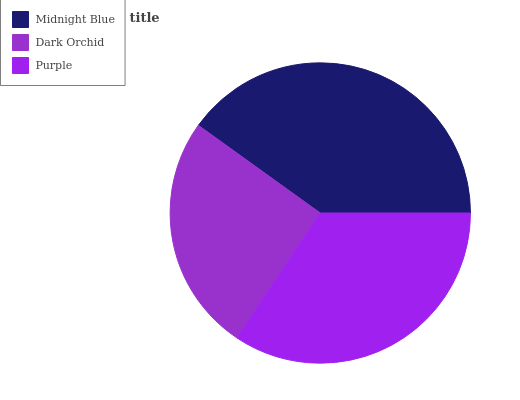Is Dark Orchid the minimum?
Answer yes or no. Yes. Is Midnight Blue the maximum?
Answer yes or no. Yes. Is Purple the minimum?
Answer yes or no. No. Is Purple the maximum?
Answer yes or no. No. Is Purple greater than Dark Orchid?
Answer yes or no. Yes. Is Dark Orchid less than Purple?
Answer yes or no. Yes. Is Dark Orchid greater than Purple?
Answer yes or no. No. Is Purple less than Dark Orchid?
Answer yes or no. No. Is Purple the high median?
Answer yes or no. Yes. Is Purple the low median?
Answer yes or no. Yes. Is Dark Orchid the high median?
Answer yes or no. No. Is Midnight Blue the low median?
Answer yes or no. No. 